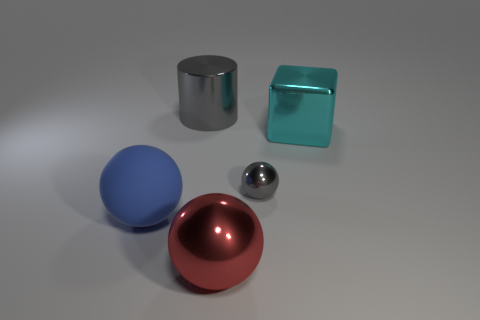Add 1 gray rubber things. How many objects exist? 6 Subtract all cylinders. How many objects are left? 4 Subtract all large cyan blocks. Subtract all gray rubber things. How many objects are left? 4 Add 1 big blue matte spheres. How many big blue matte spheres are left? 2 Add 5 big blue objects. How many big blue objects exist? 6 Subtract 0 red cylinders. How many objects are left? 5 